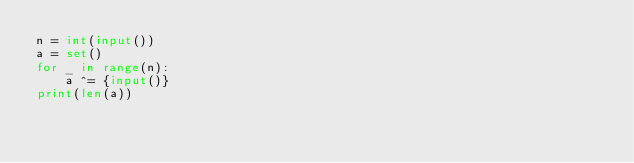Convert code to text. <code><loc_0><loc_0><loc_500><loc_500><_Python_>n = int(input())
a = set()
for _ in range(n):
    a ^= {input()}
print(len(a))</code> 